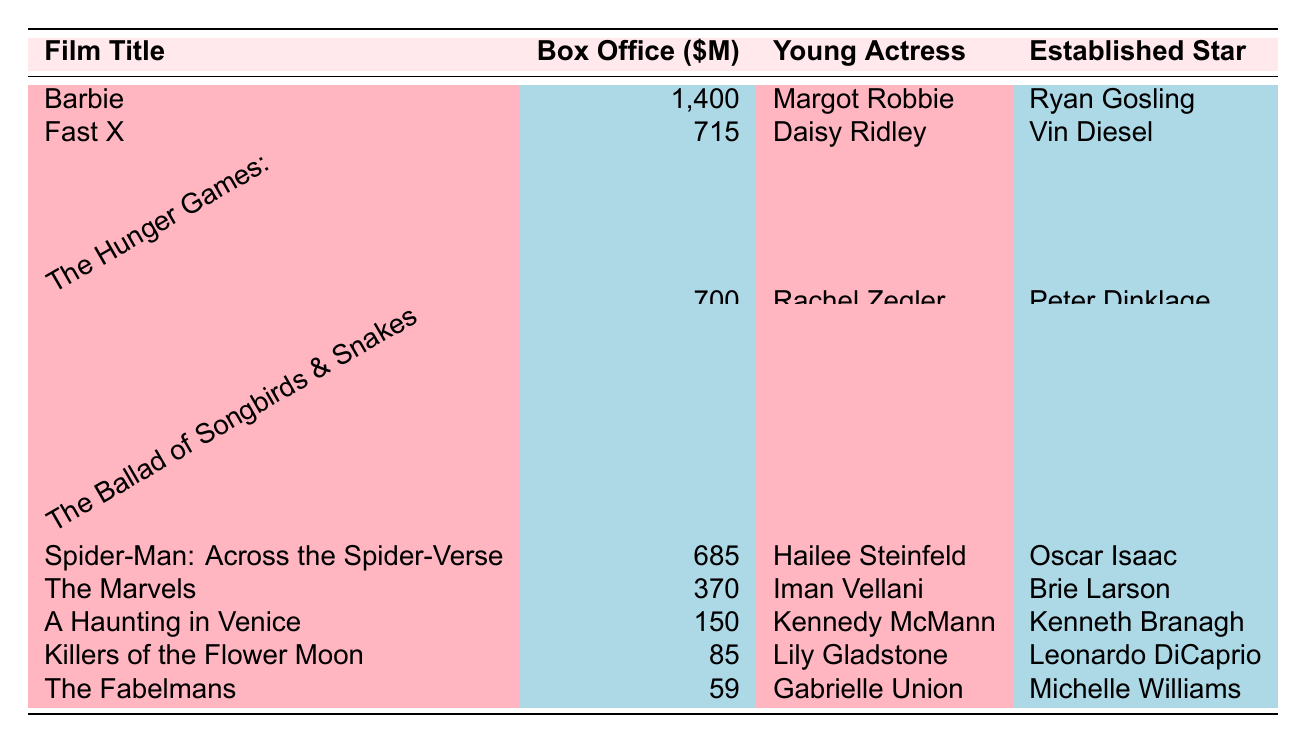What is the box office earnings of "Barbie"? The box office earnings for "Barbie" is listed directly in the table, which shows it earned 1,400 million dollars.
Answer: 1,400 million dollars Which film featuring a young actress had the highest box office earnings? The film with the highest box office earnings is "Barbie," with earnings of 1,400 million dollars, which is more than any other film listed.
Answer: "Barbie" How much more did "Fast X" earn compared to "The Fabelmans"? "Fast X" earned 715 million dollars while "The Fabelmans" earned 59 million dollars. The difference is calculated as 715 - 59 = 656 million dollars.
Answer: 656 million dollars Are there any films that earned less than 100 million dollars? The earnings of "The Fabelmans" (59 million) and "Killers of the Flower Moon" (85 million) are both under 100 million dollars. Thus, the answer is yes.
Answer: Yes What is the average box office earnings of the films featuring young actresses? The total earnings of films featuring young actresses are 1,400 + 715 + 700 + 685 + 370 + 150 + 85 + 59 = 4,064 million dollars. There are 8 films, so the average is 4,064 / 8 = 508 million dollars.
Answer: 508 million dollars Which young actress appeared in a film that earned 150 million dollars or more, but less than 700 million dollars? The films "A Haunting in Venice" (150 million) and "Spider-Man: Across the Spider-Verse" (685 million) do not fit this criterion. However, "Fast X" (715 million) exceeds this, hence the answer is "A Haunting in Venice" starring Kennedy McMann.
Answer: "A Haunting in Venice" How do the earnings of the films featuring established stars compare to those featuring young actresses? Adding the box office earnings of the established stars: 1,400 (Barbie) + 715 (Fast X) + 700 (The Hunger Games) + 685 (Spider-Man) + 370 (The Marvels) + 150 (A Haunting in Venice) + 85 (Killers of the Flower Moon) + 59 (The Fabelmans) gives a total of 4,064 million dollars, compared to 3,896 million dollars from the young actresses. Established stars earned more in total.
Answer: Established stars earned more What percentage of the total earnings does "Barbie" represent when the total box office for all films is considered? The total earnings for all films is 1,400 + 715 + 700 + 685 + 370 + 150 + 85 + 59 = 4,064 million dollars. To find the percentage "Barbie" represents, calculate (1,400 / 4,064) * 100, which is approximately 34.4%.
Answer: 34.4% Which genre had the highest box office earnings among films featuring young actresses? The genre of "Barbie" (Comedy/Fantasy) had the highest box office earnings of 1,400 million dollars, higher than any other genre listed for films featuring young actresses.
Answer: Comedy/Fantasy 